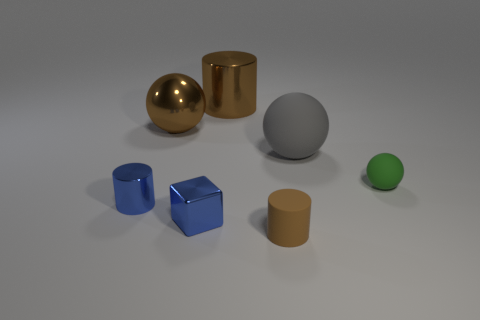Does the blue cube have the same size as the brown shiny sphere that is to the left of the big gray matte thing?
Offer a very short reply. No. What number of things are either gray rubber spheres or big yellow cylinders?
Provide a short and direct response. 1. How many small metallic cylinders have the same color as the shiny block?
Offer a very short reply. 1. There is another matte object that is the same size as the green rubber thing; what shape is it?
Provide a succinct answer. Cylinder. Is there a gray matte object of the same shape as the small green object?
Provide a short and direct response. Yes. How many gray objects have the same material as the tiny block?
Give a very brief answer. 0. Is the brown object in front of the large gray rubber object made of the same material as the small sphere?
Give a very brief answer. Yes. Is the number of tiny blue metal things that are left of the gray thing greater than the number of big brown shiny things that are left of the green ball?
Ensure brevity in your answer.  No. There is a block that is the same size as the blue metallic cylinder; what material is it?
Your answer should be compact. Metal. How many other things are made of the same material as the green ball?
Your answer should be very brief. 2. 